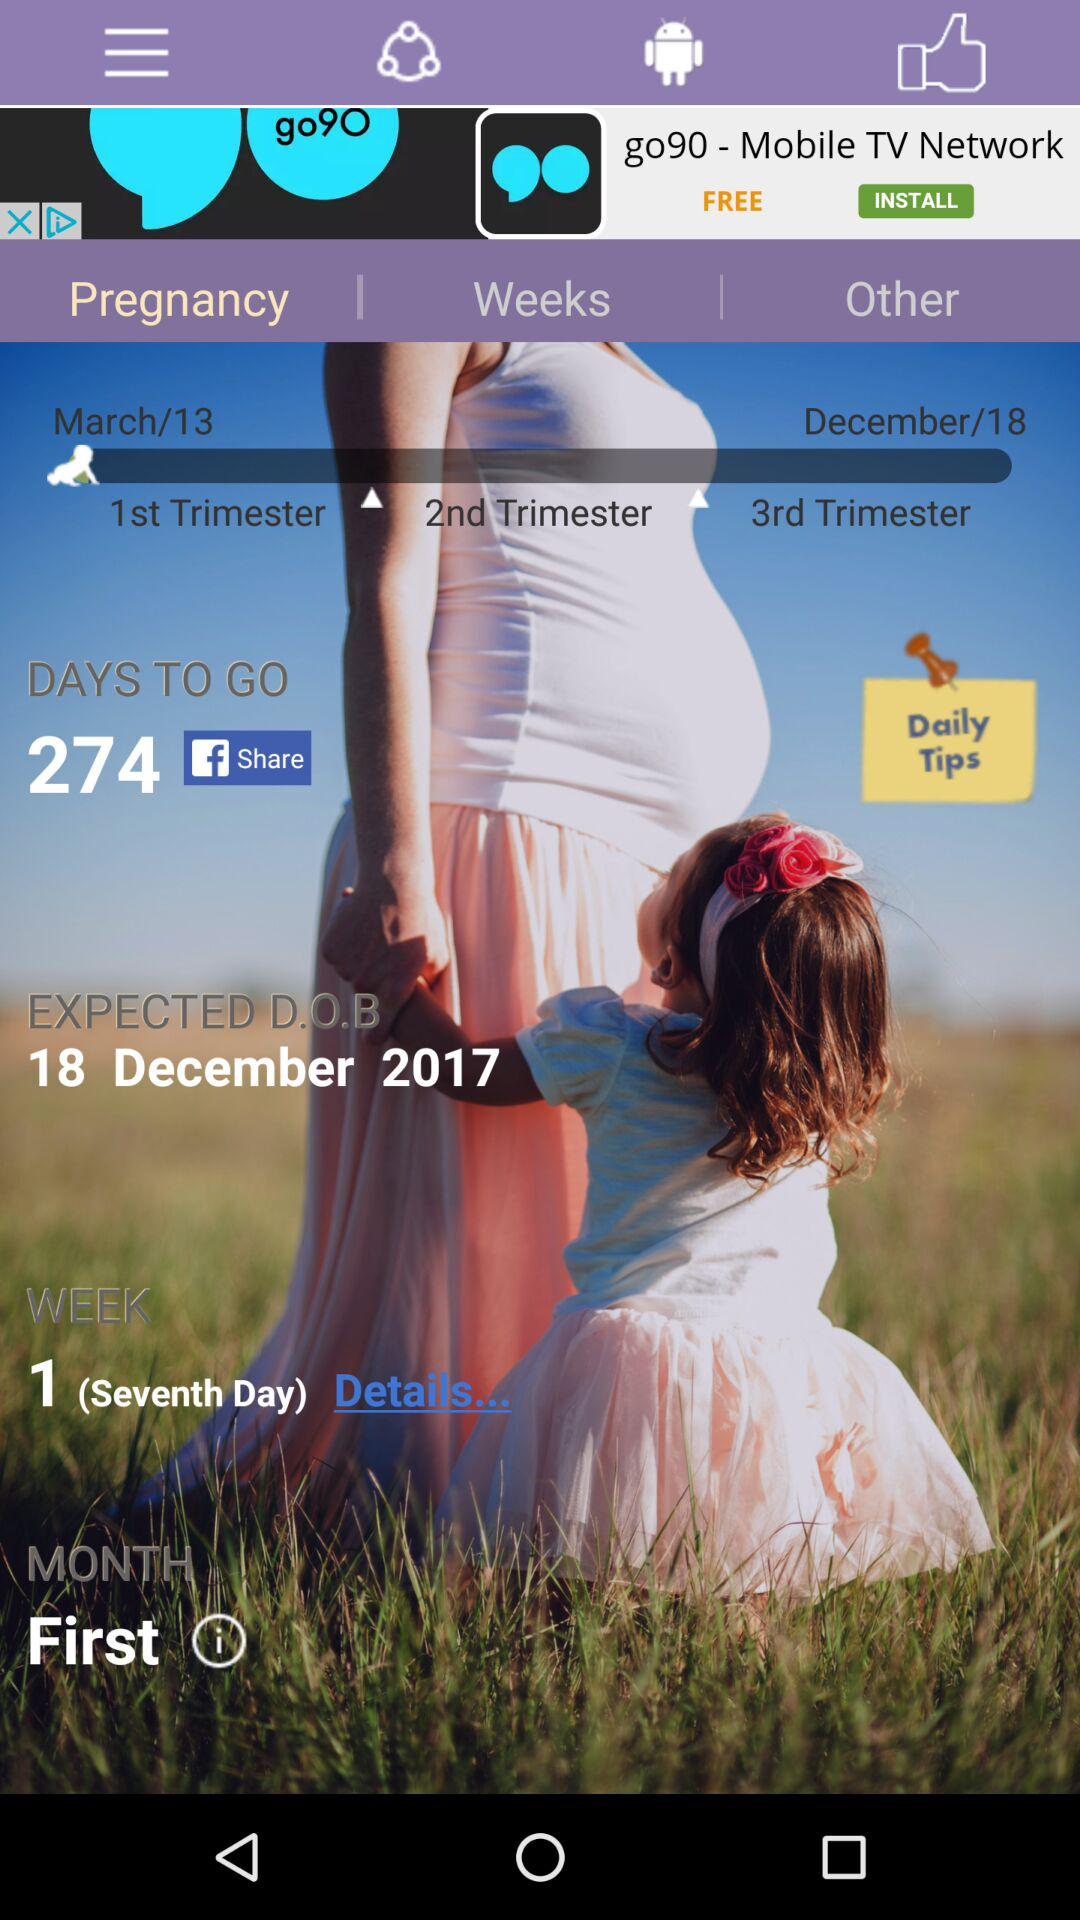How many days are left? There are 274 days left. 